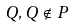Convert formula to latex. <formula><loc_0><loc_0><loc_500><loc_500>Q , Q \notin P</formula> 